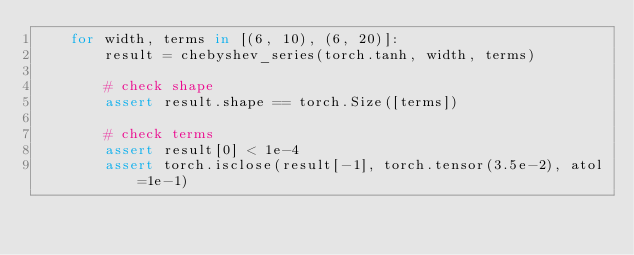<code> <loc_0><loc_0><loc_500><loc_500><_Python_>    for width, terms in [(6, 10), (6, 20)]:
        result = chebyshev_series(torch.tanh, width, terms)

        # check shape
        assert result.shape == torch.Size([terms])

        # check terms
        assert result[0] < 1e-4
        assert torch.isclose(result[-1], torch.tensor(3.5e-2), atol=1e-1)
</code> 